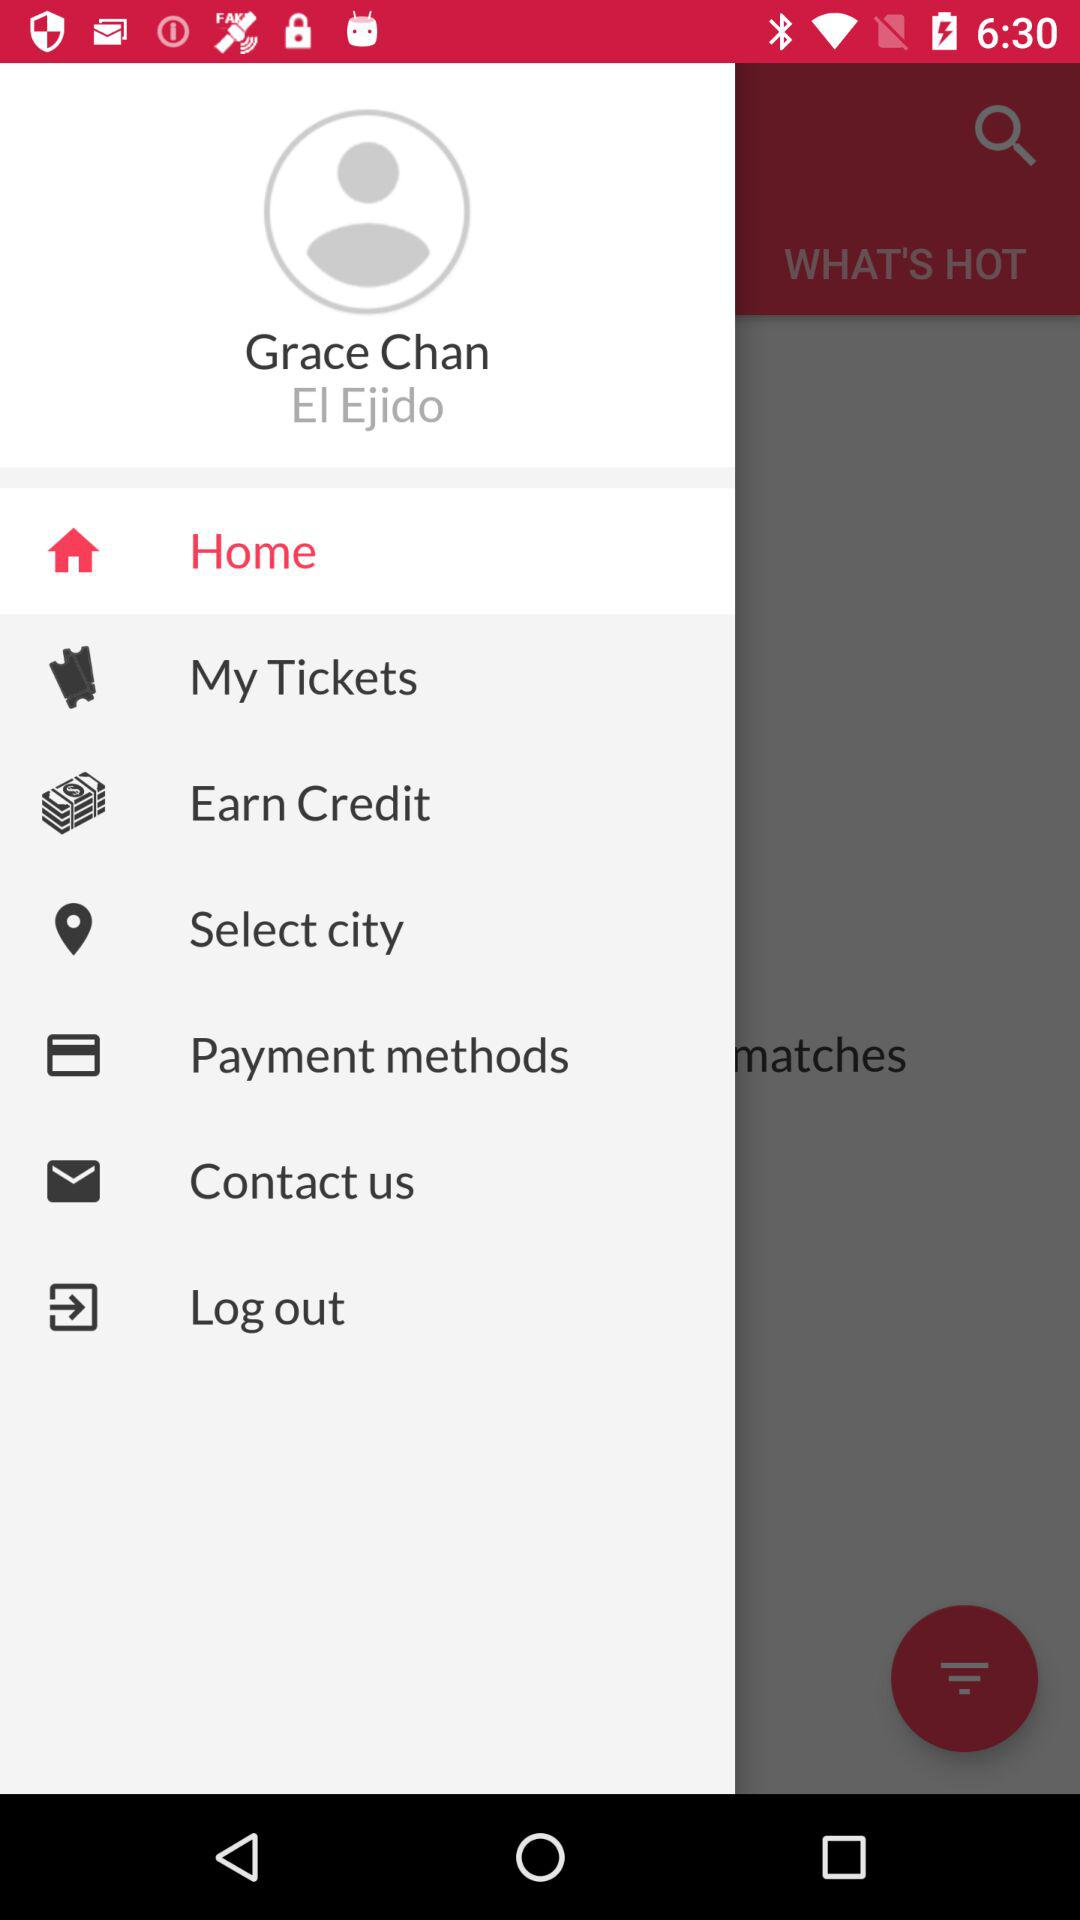What is the name of the user? The name of the user is "Grace Chan". 